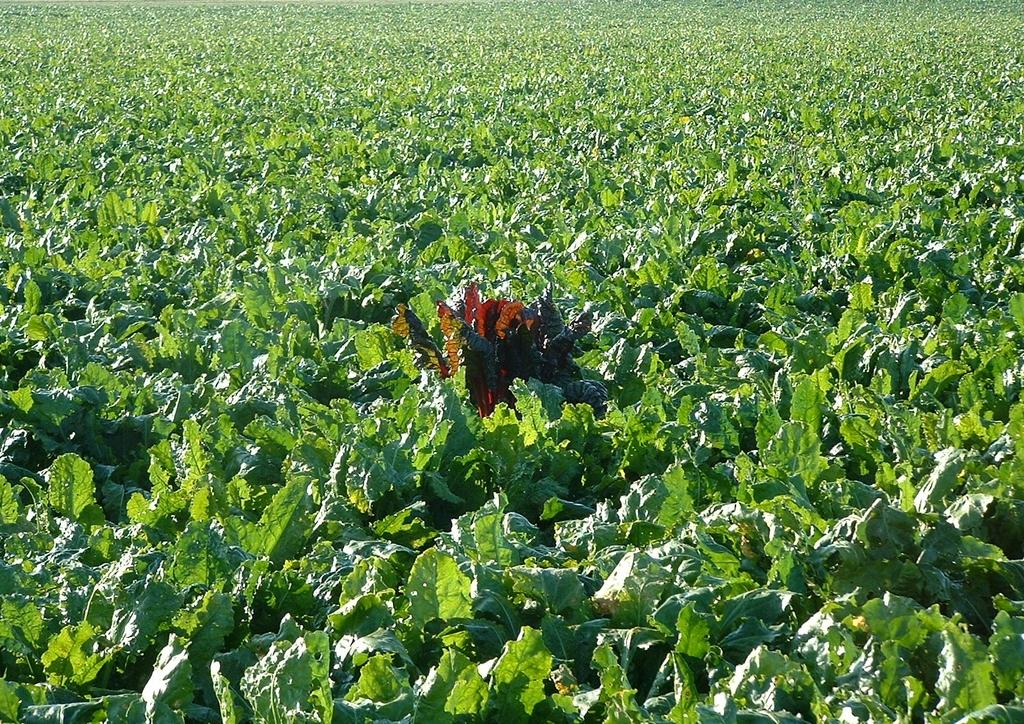What type of plants are visible in the image? There are green plants in the image. How many thumbs can be seen on the plants in the image? There are no thumbs visible on the plants in the image, as plants do not have thumbs. 